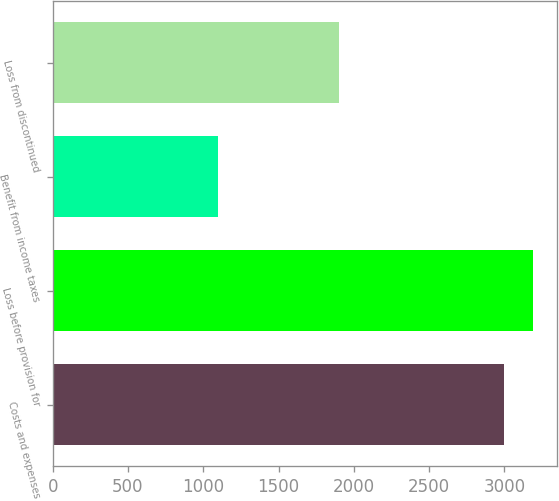<chart> <loc_0><loc_0><loc_500><loc_500><bar_chart><fcel>Costs and expenses<fcel>Loss before provision for<fcel>Benefit from income taxes<fcel>Loss from discontinued<nl><fcel>3000<fcel>3190.1<fcel>1099<fcel>1901<nl></chart> 